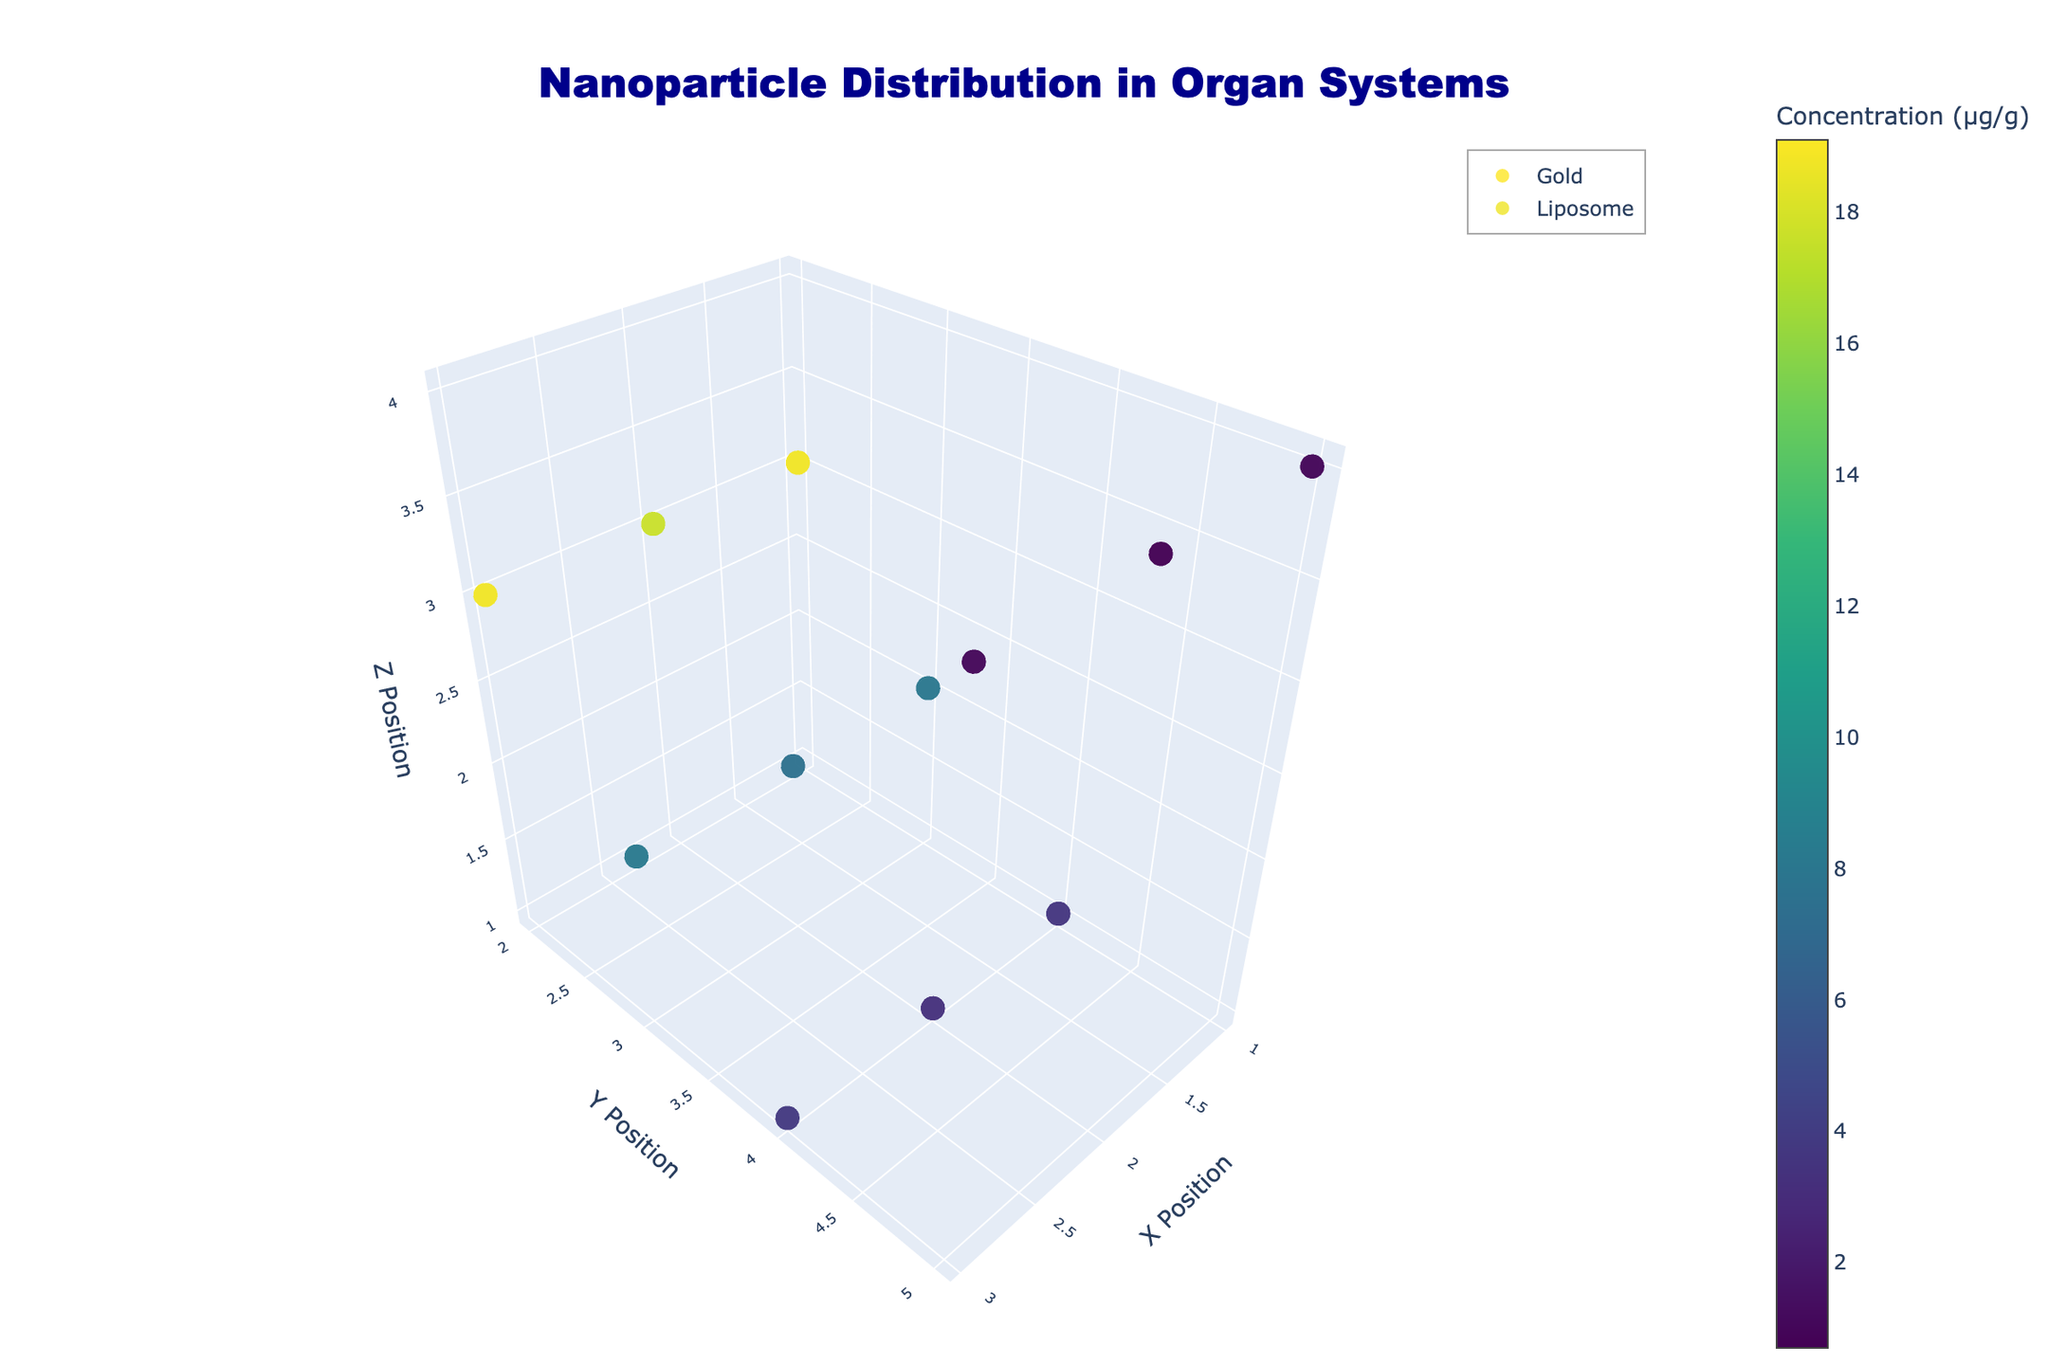What is the title of the 3D volume plot? The title is clearly displayed at the top-center of the plot in large dark blue font.
Answer: Nanoparticle Distribution in Organ Systems Which organ system has the highest concentration of gold nanoparticles? To find the highest concentration of gold nanoparticles, look at the markers colored using the Viridis colormap, and observe the values in the hover text for each organ. The Liver consistently shows the highest values.
Answer: Liver What is the average concentration of liposomes in the kidney? Identify all points representing liposomes in the kidney and sum their concentrations, then divide by the number of points (3). The concentrations are 8.2, 7.8, and 8.5, so (8.2 + 7.8 + 8.5)/3.
Answer: 8.17 Which nanoparticle type shows higher concentration levels overall? Look at the color intensity of markers for both Gold and Liposome nanoparticles. Liposome nanoparticles consistently show higher concentration values compared to the Gold nanoparticles.
Answer: Liposome What is the range of concentrations for gold nanoparticles in the lung? Inspect the hover information of the markers in the lung for gold nanoparticles and find the minimum and maximum values. Values are 2.3, 2.1, and 2.5. The range is between the smallest (2.1) and the largest (2.5).
Answer: 2.1 to 2.5 Compare the concentrations of gold nanoparticles in the brain vs. the lung. Which has the greater concentrations? Check the hover text of markers for gold nanoparticles in both the brain and the lung. The lung values (2.1 - 2.5) are higher than the brain values (0.7 - 0.9).
Answer: Lung How does the concentration of liposomes in the liver compare to the concentration of gold nanoparticles in the same organ? Look at the concentration values in the liver for both liposomes and gold nanoparticles. Liposomes have values of 17.9-19.1, whereas gold nanoparticles have values of 10.8-12.5. The liposome values are higher.
Answer: Liposomes are higher What is the total concentration of nanoparticles (all types combined) in the liver? Sum both gold and liposome concentrations in the liver. Gold: 12.5 + 10.8 + 11.2 = 34.5, Liposome: 18.7 + 17.9 + 19.1 = 55.7, and 34.5 + 55.7 = 90.2.
Answer: 90.2 How does the variance in concentrations in the brain compare between gold and liposome nanoparticles? Identify concentration variability by inspecting the spread of values in brain markers. The variance for Gold is less pronounced (values: 0.7-0.9) whereas for Liposome, it ranges from 1.0-1.3. Liposomes show slightly higher variability.
Answer: Liposomes have higher variance 